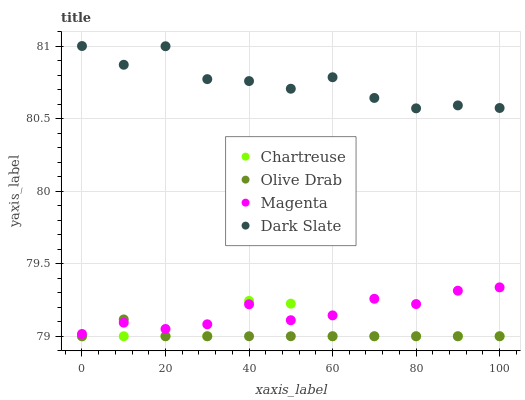Does Olive Drab have the minimum area under the curve?
Answer yes or no. Yes. Does Dark Slate have the maximum area under the curve?
Answer yes or no. Yes. Does Chartreuse have the minimum area under the curve?
Answer yes or no. No. Does Chartreuse have the maximum area under the curve?
Answer yes or no. No. Is Olive Drab the smoothest?
Answer yes or no. Yes. Is Dark Slate the roughest?
Answer yes or no. Yes. Is Chartreuse the smoothest?
Answer yes or no. No. Is Chartreuse the roughest?
Answer yes or no. No. Does Chartreuse have the lowest value?
Answer yes or no. Yes. Does Magenta have the lowest value?
Answer yes or no. No. Does Dark Slate have the highest value?
Answer yes or no. Yes. Does Chartreuse have the highest value?
Answer yes or no. No. Is Magenta less than Dark Slate?
Answer yes or no. Yes. Is Dark Slate greater than Chartreuse?
Answer yes or no. Yes. Does Magenta intersect Olive Drab?
Answer yes or no. Yes. Is Magenta less than Olive Drab?
Answer yes or no. No. Is Magenta greater than Olive Drab?
Answer yes or no. No. Does Magenta intersect Dark Slate?
Answer yes or no. No. 